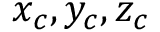Convert formula to latex. <formula><loc_0><loc_0><loc_500><loc_500>x _ { c } , y _ { c } , z _ { c }</formula> 